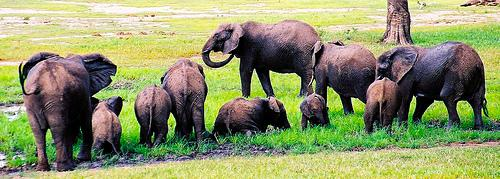Identify the main subjects in the image and provide a general overview. The image features a group of elephants, both adult and baby, standing and laying in a grassy field with trees and dirt patches around them. What objects other than the elephants can you spot in the field? There are a tree base, a tree stump, a grassy plain area, and a dirt patch in the field. How many elephants can you identify in the image? There are 9 elephants in the image. Briefly describe the environment where the animals are located. The animals are situated in a grassy field with some trees and dirt patches. Which is the biggest elephant in the image? The biggest elephant in the image is the one on the far left. Describe the unique features of the adult elephants. The adult elephants have visible trunks, tusks, large ears, and legs, and some have identifiable eyes, spines, and tails. Count the number of baby elephants in the image. There are 4 baby elephants in the image. What sentiment could you associate with the image? The sentiment associated with the image could be calm, peaceful, or serene as the elephants coexist in the grassy field. What is the condition of the elephant laying down in the grass? The elephant laying down in the grass seems to be resting, though we cannot determine its health for certain. 